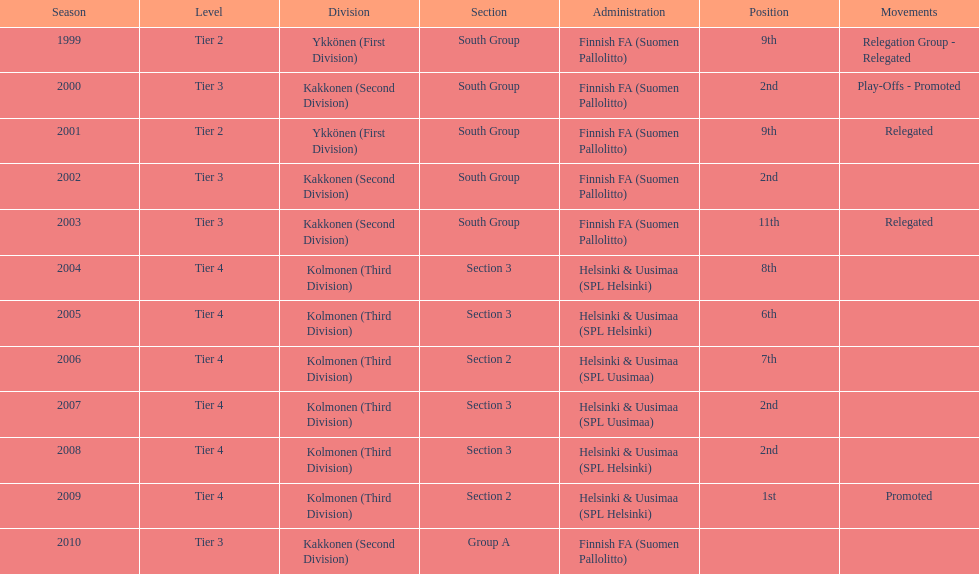How many tiers experienced over one relegation movement? 1. 